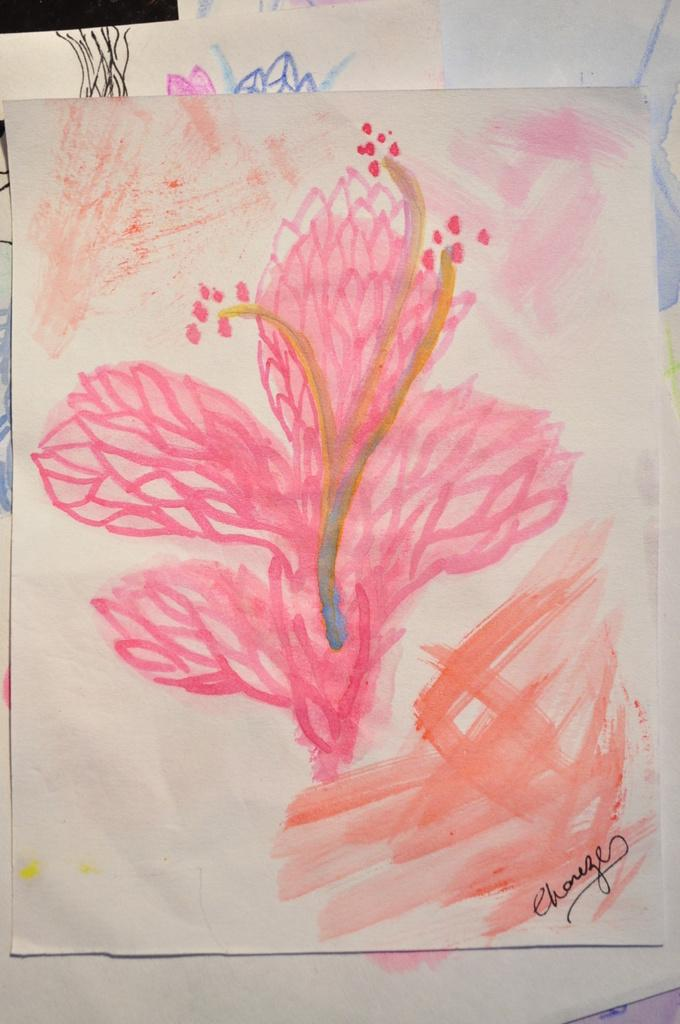What type of artwork is present in the image? The image contains pages with paintings on them. What colors are used in the paintings? The paintings are in pink and orange colors. Can you describe the background of the paintings in the image? There are papers with paintings in the background of the image. How many dogs are depicted in the paintings in the image? There are no dogs present in the paintings or the image. What type of thread is used to create the paintings in the image? The paintings are not created with thread; they are likely created with paint or other artistic mediums. 